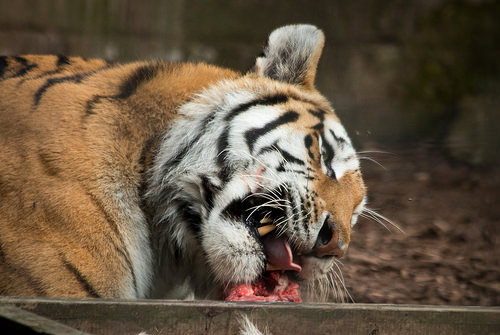<image>
Can you confirm if the tiger is on the wood? Yes. Looking at the image, I can see the tiger is positioned on top of the wood, with the wood providing support. 